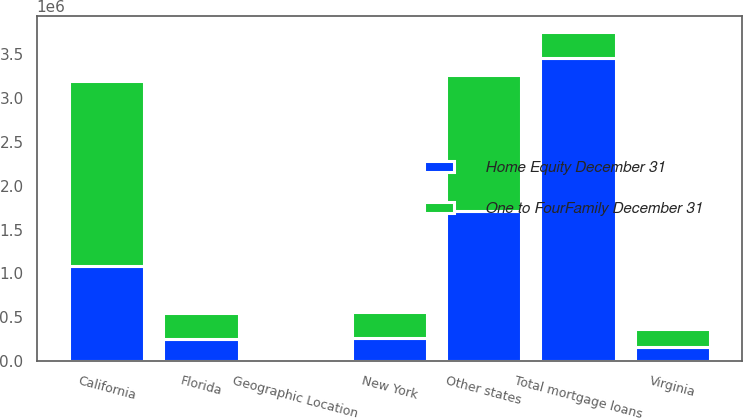<chart> <loc_0><loc_0><loc_500><loc_500><stacked_bar_chart><ecel><fcel>Geographic Location<fcel>California<fcel>New York<fcel>Florida<fcel>Virginia<fcel>Other states<fcel>Total mortgage loans<nl><fcel>One to FourFamily December 31<fcel>2013<fcel>2.11126e+06<fcel>300536<fcel>300435<fcel>205483<fcel>1.55708e+06<fcel>300435<nl><fcel>Home Equity December 31<fcel>2013<fcel>1.08286e+06<fcel>259331<fcel>246980<fcel>157721<fcel>1.70706e+06<fcel>3.45396e+06<nl></chart> 